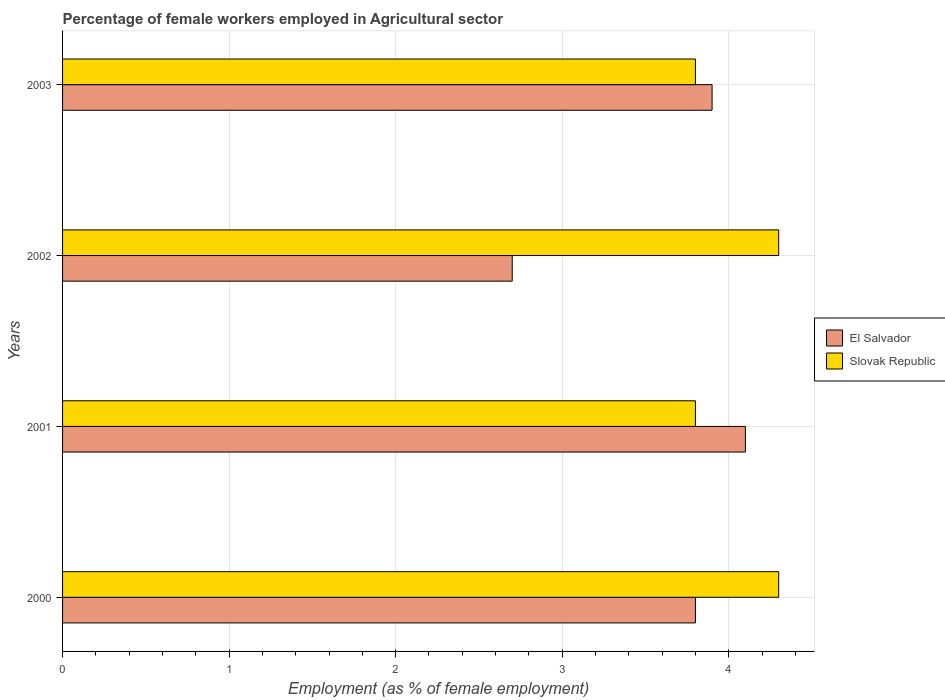How many different coloured bars are there?
Give a very brief answer. 2. Are the number of bars per tick equal to the number of legend labels?
Ensure brevity in your answer.  Yes. Are the number of bars on each tick of the Y-axis equal?
Give a very brief answer. Yes. How many bars are there on the 3rd tick from the top?
Provide a succinct answer. 2. What is the percentage of females employed in Agricultural sector in Slovak Republic in 2000?
Your answer should be very brief. 4.3. Across all years, what is the maximum percentage of females employed in Agricultural sector in El Salvador?
Keep it short and to the point. 4.1. Across all years, what is the minimum percentage of females employed in Agricultural sector in El Salvador?
Provide a short and direct response. 2.7. In which year was the percentage of females employed in Agricultural sector in Slovak Republic maximum?
Offer a terse response. 2000. In which year was the percentage of females employed in Agricultural sector in El Salvador minimum?
Offer a very short reply. 2002. What is the total percentage of females employed in Agricultural sector in El Salvador in the graph?
Offer a very short reply. 14.5. What is the difference between the percentage of females employed in Agricultural sector in Slovak Republic in 2000 and that in 2001?
Ensure brevity in your answer.  0.5. What is the difference between the percentage of females employed in Agricultural sector in El Salvador in 2001 and the percentage of females employed in Agricultural sector in Slovak Republic in 2002?
Make the answer very short. -0.2. What is the average percentage of females employed in Agricultural sector in El Salvador per year?
Your answer should be very brief. 3.62. In the year 2002, what is the difference between the percentage of females employed in Agricultural sector in Slovak Republic and percentage of females employed in Agricultural sector in El Salvador?
Offer a terse response. 1.6. In how many years, is the percentage of females employed in Agricultural sector in Slovak Republic greater than 4.2 %?
Give a very brief answer. 2. What is the ratio of the percentage of females employed in Agricultural sector in Slovak Republic in 2000 to that in 2003?
Offer a terse response. 1.13. What is the difference between the highest and the second highest percentage of females employed in Agricultural sector in Slovak Republic?
Offer a very short reply. 0. What is the difference between the highest and the lowest percentage of females employed in Agricultural sector in El Salvador?
Ensure brevity in your answer.  1.4. In how many years, is the percentage of females employed in Agricultural sector in Slovak Republic greater than the average percentage of females employed in Agricultural sector in Slovak Republic taken over all years?
Give a very brief answer. 2. What does the 1st bar from the top in 2001 represents?
Ensure brevity in your answer.  Slovak Republic. What does the 1st bar from the bottom in 2002 represents?
Give a very brief answer. El Salvador. Are all the bars in the graph horizontal?
Give a very brief answer. Yes. How many years are there in the graph?
Provide a short and direct response. 4. What is the difference between two consecutive major ticks on the X-axis?
Make the answer very short. 1. Are the values on the major ticks of X-axis written in scientific E-notation?
Ensure brevity in your answer.  No. Does the graph contain grids?
Provide a succinct answer. Yes. Where does the legend appear in the graph?
Ensure brevity in your answer.  Center right. How are the legend labels stacked?
Ensure brevity in your answer.  Vertical. What is the title of the graph?
Provide a short and direct response. Percentage of female workers employed in Agricultural sector. What is the label or title of the X-axis?
Your answer should be very brief. Employment (as % of female employment). What is the label or title of the Y-axis?
Ensure brevity in your answer.  Years. What is the Employment (as % of female employment) in El Salvador in 2000?
Make the answer very short. 3.8. What is the Employment (as % of female employment) in Slovak Republic in 2000?
Provide a short and direct response. 4.3. What is the Employment (as % of female employment) in El Salvador in 2001?
Ensure brevity in your answer.  4.1. What is the Employment (as % of female employment) in Slovak Republic in 2001?
Offer a terse response. 3.8. What is the Employment (as % of female employment) in El Salvador in 2002?
Give a very brief answer. 2.7. What is the Employment (as % of female employment) in Slovak Republic in 2002?
Ensure brevity in your answer.  4.3. What is the Employment (as % of female employment) in El Salvador in 2003?
Your answer should be compact. 3.9. What is the Employment (as % of female employment) in Slovak Republic in 2003?
Give a very brief answer. 3.8. Across all years, what is the maximum Employment (as % of female employment) in El Salvador?
Offer a very short reply. 4.1. Across all years, what is the maximum Employment (as % of female employment) in Slovak Republic?
Provide a succinct answer. 4.3. Across all years, what is the minimum Employment (as % of female employment) of El Salvador?
Ensure brevity in your answer.  2.7. Across all years, what is the minimum Employment (as % of female employment) in Slovak Republic?
Make the answer very short. 3.8. What is the total Employment (as % of female employment) of El Salvador in the graph?
Offer a very short reply. 14.5. What is the total Employment (as % of female employment) of Slovak Republic in the graph?
Your answer should be very brief. 16.2. What is the difference between the Employment (as % of female employment) of El Salvador in 2000 and that in 2001?
Your answer should be compact. -0.3. What is the difference between the Employment (as % of female employment) in Slovak Republic in 2000 and that in 2003?
Provide a short and direct response. 0.5. What is the difference between the Employment (as % of female employment) of El Salvador in 2001 and that in 2003?
Keep it short and to the point. 0.2. What is the difference between the Employment (as % of female employment) in El Salvador in 2002 and that in 2003?
Provide a short and direct response. -1.2. What is the difference between the Employment (as % of female employment) of Slovak Republic in 2002 and that in 2003?
Keep it short and to the point. 0.5. What is the difference between the Employment (as % of female employment) in El Salvador in 2000 and the Employment (as % of female employment) in Slovak Republic in 2002?
Provide a short and direct response. -0.5. What is the difference between the Employment (as % of female employment) of El Salvador in 2000 and the Employment (as % of female employment) of Slovak Republic in 2003?
Your answer should be very brief. 0. What is the difference between the Employment (as % of female employment) of El Salvador in 2001 and the Employment (as % of female employment) of Slovak Republic in 2002?
Offer a terse response. -0.2. What is the difference between the Employment (as % of female employment) in El Salvador in 2002 and the Employment (as % of female employment) in Slovak Republic in 2003?
Your response must be concise. -1.1. What is the average Employment (as % of female employment) of El Salvador per year?
Give a very brief answer. 3.62. What is the average Employment (as % of female employment) in Slovak Republic per year?
Your answer should be very brief. 4.05. In the year 2000, what is the difference between the Employment (as % of female employment) in El Salvador and Employment (as % of female employment) in Slovak Republic?
Your answer should be very brief. -0.5. What is the ratio of the Employment (as % of female employment) of El Salvador in 2000 to that in 2001?
Provide a succinct answer. 0.93. What is the ratio of the Employment (as % of female employment) in Slovak Republic in 2000 to that in 2001?
Your response must be concise. 1.13. What is the ratio of the Employment (as % of female employment) of El Salvador in 2000 to that in 2002?
Offer a very short reply. 1.41. What is the ratio of the Employment (as % of female employment) of El Salvador in 2000 to that in 2003?
Ensure brevity in your answer.  0.97. What is the ratio of the Employment (as % of female employment) of Slovak Republic in 2000 to that in 2003?
Provide a short and direct response. 1.13. What is the ratio of the Employment (as % of female employment) in El Salvador in 2001 to that in 2002?
Make the answer very short. 1.52. What is the ratio of the Employment (as % of female employment) of Slovak Republic in 2001 to that in 2002?
Keep it short and to the point. 0.88. What is the ratio of the Employment (as % of female employment) of El Salvador in 2001 to that in 2003?
Offer a very short reply. 1.05. What is the ratio of the Employment (as % of female employment) in El Salvador in 2002 to that in 2003?
Your response must be concise. 0.69. What is the ratio of the Employment (as % of female employment) in Slovak Republic in 2002 to that in 2003?
Ensure brevity in your answer.  1.13. What is the difference between the highest and the second highest Employment (as % of female employment) of El Salvador?
Offer a very short reply. 0.2. What is the difference between the highest and the lowest Employment (as % of female employment) in El Salvador?
Make the answer very short. 1.4. 